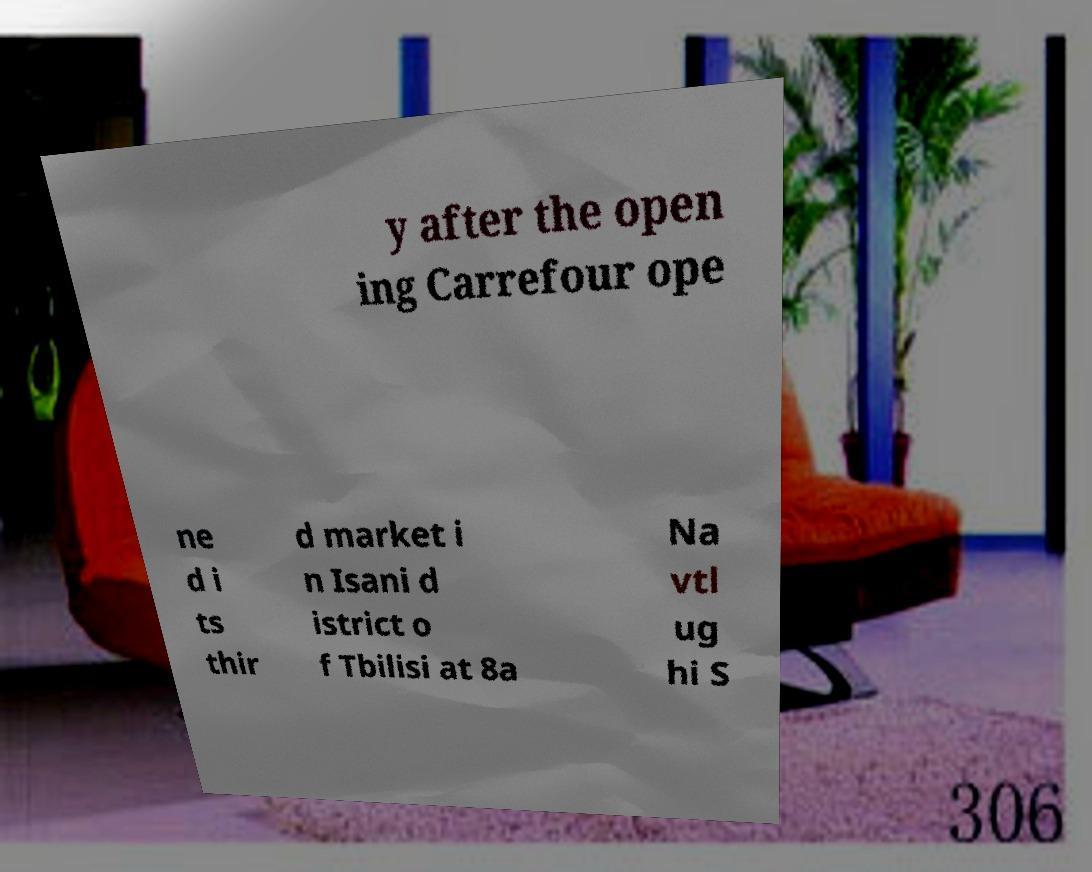Please identify and transcribe the text found in this image. y after the open ing Carrefour ope ne d i ts thir d market i n Isani d istrict o f Tbilisi at 8a Na vtl ug hi S 